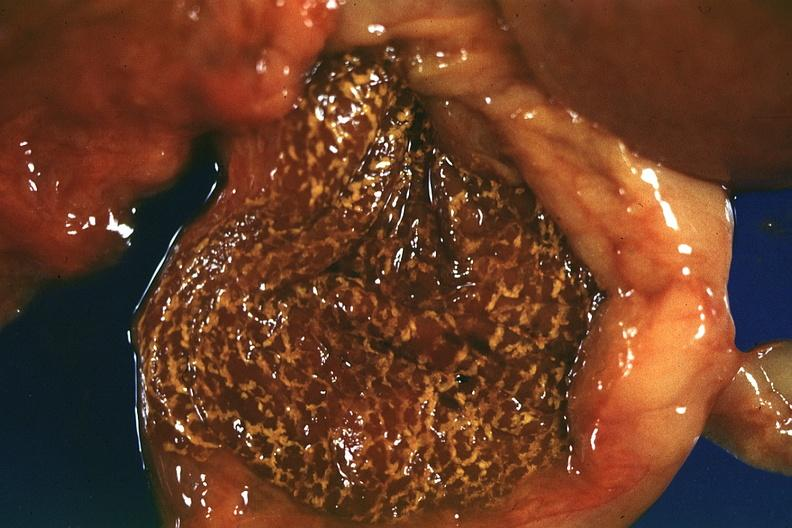s cytomegaly present?
Answer the question using a single word or phrase. No 